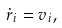Convert formula to latex. <formula><loc_0><loc_0><loc_500><loc_500>\dot { r } _ { i } = { v } _ { i } ,</formula> 